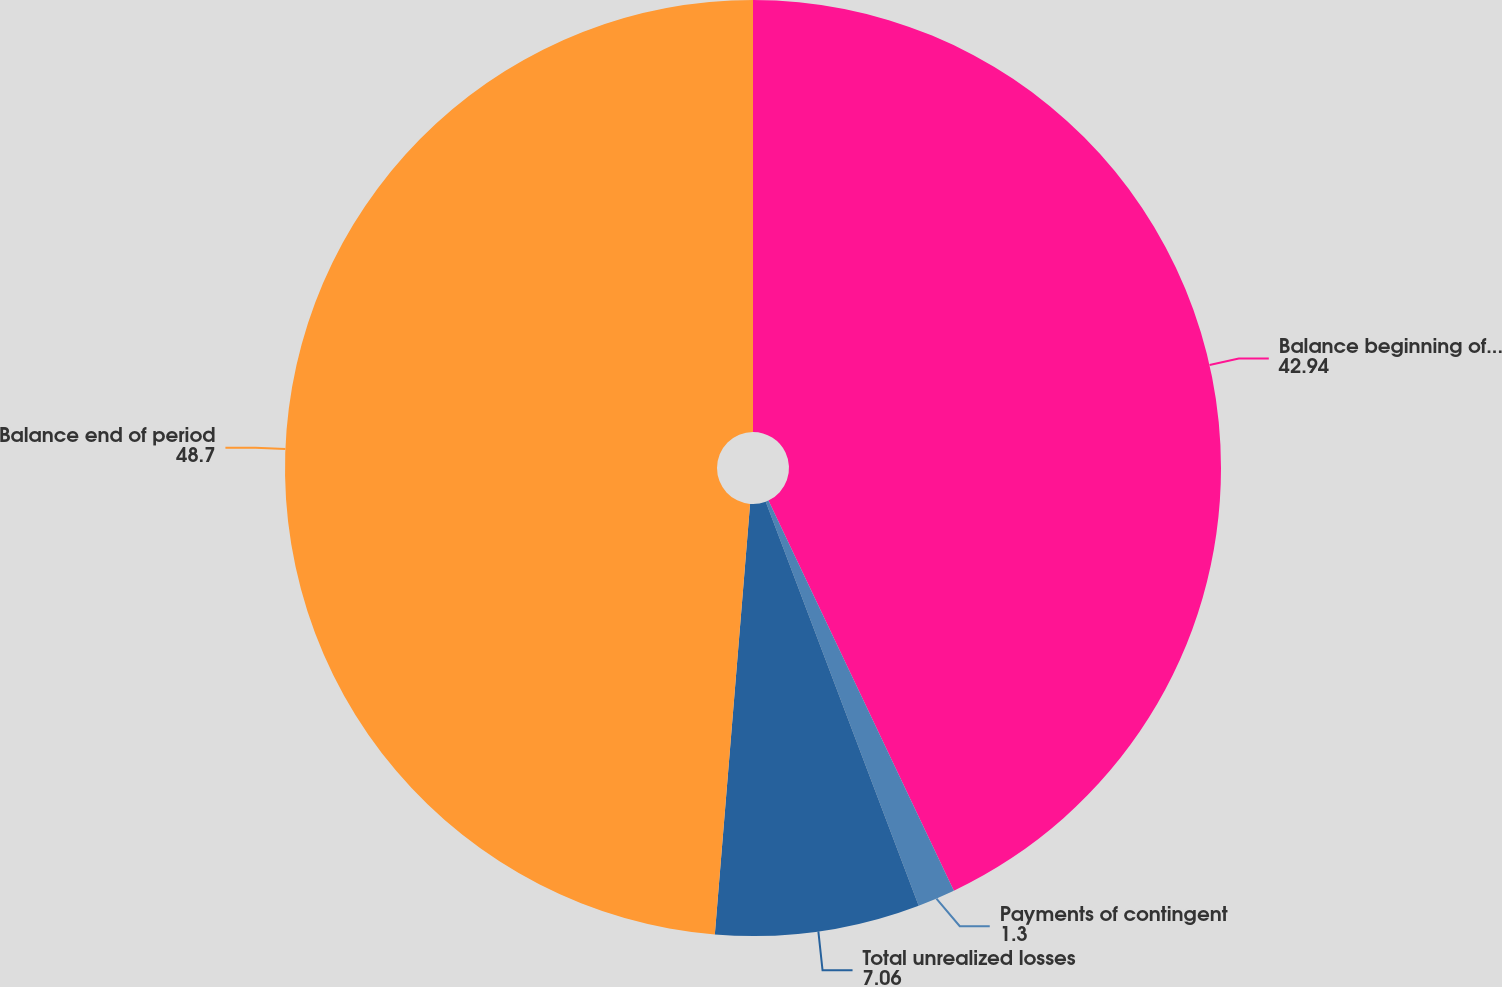Convert chart to OTSL. <chart><loc_0><loc_0><loc_500><loc_500><pie_chart><fcel>Balance beginning of period<fcel>Payments of contingent<fcel>Total unrealized losses<fcel>Balance end of period<nl><fcel>42.94%<fcel>1.3%<fcel>7.06%<fcel>48.7%<nl></chart> 